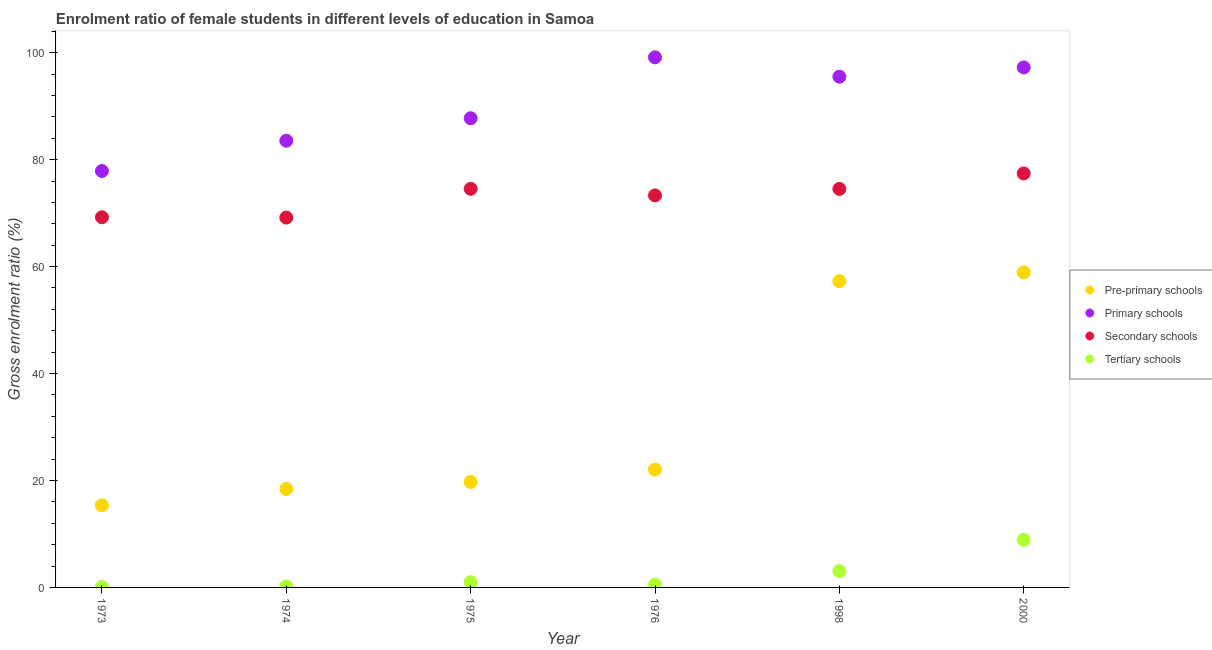How many different coloured dotlines are there?
Your response must be concise. 4. Is the number of dotlines equal to the number of legend labels?
Provide a succinct answer. Yes. What is the gross enrolment ratio(male) in primary schools in 1976?
Make the answer very short. 99.14. Across all years, what is the maximum gross enrolment ratio(male) in pre-primary schools?
Give a very brief answer. 58.91. Across all years, what is the minimum gross enrolment ratio(male) in pre-primary schools?
Ensure brevity in your answer.  15.36. In which year was the gross enrolment ratio(male) in primary schools maximum?
Make the answer very short. 1976. What is the total gross enrolment ratio(male) in pre-primary schools in the graph?
Your answer should be very brief. 191.72. What is the difference between the gross enrolment ratio(male) in secondary schools in 1975 and that in 1976?
Make the answer very short. 1.23. What is the difference between the gross enrolment ratio(male) in primary schools in 1976 and the gross enrolment ratio(male) in secondary schools in 1973?
Your answer should be very brief. 29.91. What is the average gross enrolment ratio(male) in tertiary schools per year?
Give a very brief answer. 2.29. In the year 2000, what is the difference between the gross enrolment ratio(male) in pre-primary schools and gross enrolment ratio(male) in tertiary schools?
Ensure brevity in your answer.  50. What is the ratio of the gross enrolment ratio(male) in tertiary schools in 1975 to that in 2000?
Your response must be concise. 0.11. Is the gross enrolment ratio(male) in pre-primary schools in 1975 less than that in 2000?
Keep it short and to the point. Yes. Is the difference between the gross enrolment ratio(male) in secondary schools in 1973 and 2000 greater than the difference between the gross enrolment ratio(male) in pre-primary schools in 1973 and 2000?
Offer a terse response. Yes. What is the difference between the highest and the second highest gross enrolment ratio(male) in pre-primary schools?
Give a very brief answer. 1.63. What is the difference between the highest and the lowest gross enrolment ratio(male) in pre-primary schools?
Provide a succinct answer. 43.55. Is the sum of the gross enrolment ratio(male) in tertiary schools in 1975 and 1976 greater than the maximum gross enrolment ratio(male) in secondary schools across all years?
Ensure brevity in your answer.  No. Is it the case that in every year, the sum of the gross enrolment ratio(male) in pre-primary schools and gross enrolment ratio(male) in tertiary schools is greater than the sum of gross enrolment ratio(male) in primary schools and gross enrolment ratio(male) in secondary schools?
Your answer should be compact. No. Is the gross enrolment ratio(male) in pre-primary schools strictly less than the gross enrolment ratio(male) in primary schools over the years?
Provide a short and direct response. Yes. How many years are there in the graph?
Ensure brevity in your answer.  6. Are the values on the major ticks of Y-axis written in scientific E-notation?
Give a very brief answer. No. Does the graph contain any zero values?
Offer a terse response. No. Does the graph contain grids?
Your answer should be compact. No. Where does the legend appear in the graph?
Provide a short and direct response. Center right. How are the legend labels stacked?
Keep it short and to the point. Vertical. What is the title of the graph?
Provide a succinct answer. Enrolment ratio of female students in different levels of education in Samoa. What is the label or title of the Y-axis?
Provide a succinct answer. Gross enrolment ratio (%). What is the Gross enrolment ratio (%) in Pre-primary schools in 1973?
Provide a short and direct response. 15.36. What is the Gross enrolment ratio (%) of Primary schools in 1973?
Your answer should be compact. 77.88. What is the Gross enrolment ratio (%) of Secondary schools in 1973?
Ensure brevity in your answer.  69.23. What is the Gross enrolment ratio (%) of Tertiary schools in 1973?
Provide a succinct answer. 0.09. What is the Gross enrolment ratio (%) of Pre-primary schools in 1974?
Make the answer very short. 18.42. What is the Gross enrolment ratio (%) of Primary schools in 1974?
Keep it short and to the point. 83.54. What is the Gross enrolment ratio (%) in Secondary schools in 1974?
Ensure brevity in your answer.  69.17. What is the Gross enrolment ratio (%) of Tertiary schools in 1974?
Ensure brevity in your answer.  0.18. What is the Gross enrolment ratio (%) of Pre-primary schools in 1975?
Give a very brief answer. 19.73. What is the Gross enrolment ratio (%) in Primary schools in 1975?
Provide a short and direct response. 87.74. What is the Gross enrolment ratio (%) in Secondary schools in 1975?
Your answer should be very brief. 74.55. What is the Gross enrolment ratio (%) of Tertiary schools in 1975?
Your response must be concise. 0.98. What is the Gross enrolment ratio (%) in Pre-primary schools in 1976?
Give a very brief answer. 22.04. What is the Gross enrolment ratio (%) in Primary schools in 1976?
Offer a terse response. 99.14. What is the Gross enrolment ratio (%) in Secondary schools in 1976?
Your response must be concise. 73.32. What is the Gross enrolment ratio (%) of Tertiary schools in 1976?
Provide a succinct answer. 0.54. What is the Gross enrolment ratio (%) of Pre-primary schools in 1998?
Ensure brevity in your answer.  57.27. What is the Gross enrolment ratio (%) of Primary schools in 1998?
Offer a very short reply. 95.51. What is the Gross enrolment ratio (%) in Secondary schools in 1998?
Ensure brevity in your answer.  74.53. What is the Gross enrolment ratio (%) in Tertiary schools in 1998?
Keep it short and to the point. 3.05. What is the Gross enrolment ratio (%) of Pre-primary schools in 2000?
Offer a very short reply. 58.91. What is the Gross enrolment ratio (%) of Primary schools in 2000?
Your answer should be compact. 97.25. What is the Gross enrolment ratio (%) of Secondary schools in 2000?
Provide a short and direct response. 77.42. What is the Gross enrolment ratio (%) of Tertiary schools in 2000?
Keep it short and to the point. 8.91. Across all years, what is the maximum Gross enrolment ratio (%) in Pre-primary schools?
Make the answer very short. 58.91. Across all years, what is the maximum Gross enrolment ratio (%) in Primary schools?
Offer a very short reply. 99.14. Across all years, what is the maximum Gross enrolment ratio (%) of Secondary schools?
Your answer should be compact. 77.42. Across all years, what is the maximum Gross enrolment ratio (%) in Tertiary schools?
Make the answer very short. 8.91. Across all years, what is the minimum Gross enrolment ratio (%) in Pre-primary schools?
Provide a succinct answer. 15.36. Across all years, what is the minimum Gross enrolment ratio (%) of Primary schools?
Provide a succinct answer. 77.88. Across all years, what is the minimum Gross enrolment ratio (%) of Secondary schools?
Your response must be concise. 69.17. Across all years, what is the minimum Gross enrolment ratio (%) in Tertiary schools?
Your answer should be compact. 0.09. What is the total Gross enrolment ratio (%) of Pre-primary schools in the graph?
Provide a short and direct response. 191.72. What is the total Gross enrolment ratio (%) in Primary schools in the graph?
Make the answer very short. 541.07. What is the total Gross enrolment ratio (%) in Secondary schools in the graph?
Offer a very short reply. 438.2. What is the total Gross enrolment ratio (%) in Tertiary schools in the graph?
Offer a terse response. 13.75. What is the difference between the Gross enrolment ratio (%) of Pre-primary schools in 1973 and that in 1974?
Ensure brevity in your answer.  -3.06. What is the difference between the Gross enrolment ratio (%) of Primary schools in 1973 and that in 1974?
Your response must be concise. -5.66. What is the difference between the Gross enrolment ratio (%) of Secondary schools in 1973 and that in 1974?
Provide a succinct answer. 0.06. What is the difference between the Gross enrolment ratio (%) of Tertiary schools in 1973 and that in 1974?
Give a very brief answer. -0.09. What is the difference between the Gross enrolment ratio (%) of Pre-primary schools in 1973 and that in 1975?
Provide a succinct answer. -4.38. What is the difference between the Gross enrolment ratio (%) of Primary schools in 1973 and that in 1975?
Offer a terse response. -9.86. What is the difference between the Gross enrolment ratio (%) in Secondary schools in 1973 and that in 1975?
Offer a terse response. -5.32. What is the difference between the Gross enrolment ratio (%) of Tertiary schools in 1973 and that in 1975?
Keep it short and to the point. -0.88. What is the difference between the Gross enrolment ratio (%) of Pre-primary schools in 1973 and that in 1976?
Your response must be concise. -6.68. What is the difference between the Gross enrolment ratio (%) in Primary schools in 1973 and that in 1976?
Offer a very short reply. -21.26. What is the difference between the Gross enrolment ratio (%) in Secondary schools in 1973 and that in 1976?
Keep it short and to the point. -4.09. What is the difference between the Gross enrolment ratio (%) in Tertiary schools in 1973 and that in 1976?
Offer a very short reply. -0.44. What is the difference between the Gross enrolment ratio (%) of Pre-primary schools in 1973 and that in 1998?
Keep it short and to the point. -41.92. What is the difference between the Gross enrolment ratio (%) in Primary schools in 1973 and that in 1998?
Provide a succinct answer. -17.63. What is the difference between the Gross enrolment ratio (%) in Secondary schools in 1973 and that in 1998?
Offer a very short reply. -5.3. What is the difference between the Gross enrolment ratio (%) in Tertiary schools in 1973 and that in 1998?
Keep it short and to the point. -2.96. What is the difference between the Gross enrolment ratio (%) of Pre-primary schools in 1973 and that in 2000?
Offer a terse response. -43.55. What is the difference between the Gross enrolment ratio (%) in Primary schools in 1973 and that in 2000?
Give a very brief answer. -19.37. What is the difference between the Gross enrolment ratio (%) in Secondary schools in 1973 and that in 2000?
Provide a succinct answer. -8.2. What is the difference between the Gross enrolment ratio (%) of Tertiary schools in 1973 and that in 2000?
Your answer should be very brief. -8.81. What is the difference between the Gross enrolment ratio (%) in Pre-primary schools in 1974 and that in 1975?
Ensure brevity in your answer.  -1.31. What is the difference between the Gross enrolment ratio (%) of Primary schools in 1974 and that in 1975?
Your answer should be very brief. -4.21. What is the difference between the Gross enrolment ratio (%) in Secondary schools in 1974 and that in 1975?
Give a very brief answer. -5.38. What is the difference between the Gross enrolment ratio (%) of Tertiary schools in 1974 and that in 1975?
Provide a succinct answer. -0.8. What is the difference between the Gross enrolment ratio (%) in Pre-primary schools in 1974 and that in 1976?
Your response must be concise. -3.62. What is the difference between the Gross enrolment ratio (%) in Primary schools in 1974 and that in 1976?
Offer a terse response. -15.6. What is the difference between the Gross enrolment ratio (%) of Secondary schools in 1974 and that in 1976?
Provide a short and direct response. -4.15. What is the difference between the Gross enrolment ratio (%) in Tertiary schools in 1974 and that in 1976?
Give a very brief answer. -0.36. What is the difference between the Gross enrolment ratio (%) of Pre-primary schools in 1974 and that in 1998?
Offer a very short reply. -38.85. What is the difference between the Gross enrolment ratio (%) in Primary schools in 1974 and that in 1998?
Provide a succinct answer. -11.97. What is the difference between the Gross enrolment ratio (%) in Secondary schools in 1974 and that in 1998?
Your response must be concise. -5.36. What is the difference between the Gross enrolment ratio (%) of Tertiary schools in 1974 and that in 1998?
Your response must be concise. -2.87. What is the difference between the Gross enrolment ratio (%) of Pre-primary schools in 1974 and that in 2000?
Your answer should be compact. -40.49. What is the difference between the Gross enrolment ratio (%) in Primary schools in 1974 and that in 2000?
Keep it short and to the point. -13.71. What is the difference between the Gross enrolment ratio (%) of Secondary schools in 1974 and that in 2000?
Give a very brief answer. -8.26. What is the difference between the Gross enrolment ratio (%) of Tertiary schools in 1974 and that in 2000?
Your response must be concise. -8.73. What is the difference between the Gross enrolment ratio (%) in Pre-primary schools in 1975 and that in 1976?
Your response must be concise. -2.31. What is the difference between the Gross enrolment ratio (%) of Primary schools in 1975 and that in 1976?
Ensure brevity in your answer.  -11.4. What is the difference between the Gross enrolment ratio (%) of Secondary schools in 1975 and that in 1976?
Offer a terse response. 1.23. What is the difference between the Gross enrolment ratio (%) of Tertiary schools in 1975 and that in 1976?
Give a very brief answer. 0.44. What is the difference between the Gross enrolment ratio (%) in Pre-primary schools in 1975 and that in 1998?
Ensure brevity in your answer.  -37.54. What is the difference between the Gross enrolment ratio (%) in Primary schools in 1975 and that in 1998?
Your answer should be compact. -7.77. What is the difference between the Gross enrolment ratio (%) in Secondary schools in 1975 and that in 1998?
Offer a very short reply. 0.02. What is the difference between the Gross enrolment ratio (%) of Tertiary schools in 1975 and that in 1998?
Provide a short and direct response. -2.08. What is the difference between the Gross enrolment ratio (%) in Pre-primary schools in 1975 and that in 2000?
Offer a very short reply. -39.18. What is the difference between the Gross enrolment ratio (%) in Primary schools in 1975 and that in 2000?
Give a very brief answer. -9.51. What is the difference between the Gross enrolment ratio (%) in Secondary schools in 1975 and that in 2000?
Give a very brief answer. -2.88. What is the difference between the Gross enrolment ratio (%) in Tertiary schools in 1975 and that in 2000?
Keep it short and to the point. -7.93. What is the difference between the Gross enrolment ratio (%) of Pre-primary schools in 1976 and that in 1998?
Keep it short and to the point. -35.23. What is the difference between the Gross enrolment ratio (%) in Primary schools in 1976 and that in 1998?
Provide a short and direct response. 3.63. What is the difference between the Gross enrolment ratio (%) in Secondary schools in 1976 and that in 1998?
Offer a terse response. -1.21. What is the difference between the Gross enrolment ratio (%) of Tertiary schools in 1976 and that in 1998?
Provide a succinct answer. -2.52. What is the difference between the Gross enrolment ratio (%) in Pre-primary schools in 1976 and that in 2000?
Ensure brevity in your answer.  -36.87. What is the difference between the Gross enrolment ratio (%) of Primary schools in 1976 and that in 2000?
Ensure brevity in your answer.  1.89. What is the difference between the Gross enrolment ratio (%) in Secondary schools in 1976 and that in 2000?
Offer a very short reply. -4.11. What is the difference between the Gross enrolment ratio (%) of Tertiary schools in 1976 and that in 2000?
Offer a very short reply. -8.37. What is the difference between the Gross enrolment ratio (%) in Pre-primary schools in 1998 and that in 2000?
Your response must be concise. -1.63. What is the difference between the Gross enrolment ratio (%) of Primary schools in 1998 and that in 2000?
Ensure brevity in your answer.  -1.74. What is the difference between the Gross enrolment ratio (%) of Secondary schools in 1998 and that in 2000?
Provide a short and direct response. -2.9. What is the difference between the Gross enrolment ratio (%) in Tertiary schools in 1998 and that in 2000?
Provide a succinct answer. -5.85. What is the difference between the Gross enrolment ratio (%) in Pre-primary schools in 1973 and the Gross enrolment ratio (%) in Primary schools in 1974?
Keep it short and to the point. -68.18. What is the difference between the Gross enrolment ratio (%) of Pre-primary schools in 1973 and the Gross enrolment ratio (%) of Secondary schools in 1974?
Provide a succinct answer. -53.81. What is the difference between the Gross enrolment ratio (%) in Pre-primary schools in 1973 and the Gross enrolment ratio (%) in Tertiary schools in 1974?
Your answer should be very brief. 15.17. What is the difference between the Gross enrolment ratio (%) of Primary schools in 1973 and the Gross enrolment ratio (%) of Secondary schools in 1974?
Give a very brief answer. 8.72. What is the difference between the Gross enrolment ratio (%) of Primary schools in 1973 and the Gross enrolment ratio (%) of Tertiary schools in 1974?
Your answer should be very brief. 77.7. What is the difference between the Gross enrolment ratio (%) of Secondary schools in 1973 and the Gross enrolment ratio (%) of Tertiary schools in 1974?
Your answer should be compact. 69.05. What is the difference between the Gross enrolment ratio (%) of Pre-primary schools in 1973 and the Gross enrolment ratio (%) of Primary schools in 1975?
Keep it short and to the point. -72.39. What is the difference between the Gross enrolment ratio (%) in Pre-primary schools in 1973 and the Gross enrolment ratio (%) in Secondary schools in 1975?
Your answer should be very brief. -59.19. What is the difference between the Gross enrolment ratio (%) of Pre-primary schools in 1973 and the Gross enrolment ratio (%) of Tertiary schools in 1975?
Keep it short and to the point. 14.38. What is the difference between the Gross enrolment ratio (%) of Primary schools in 1973 and the Gross enrolment ratio (%) of Secondary schools in 1975?
Your answer should be very brief. 3.34. What is the difference between the Gross enrolment ratio (%) in Primary schools in 1973 and the Gross enrolment ratio (%) in Tertiary schools in 1975?
Offer a very short reply. 76.9. What is the difference between the Gross enrolment ratio (%) in Secondary schools in 1973 and the Gross enrolment ratio (%) in Tertiary schools in 1975?
Your response must be concise. 68.25. What is the difference between the Gross enrolment ratio (%) in Pre-primary schools in 1973 and the Gross enrolment ratio (%) in Primary schools in 1976?
Make the answer very short. -83.79. What is the difference between the Gross enrolment ratio (%) of Pre-primary schools in 1973 and the Gross enrolment ratio (%) of Secondary schools in 1976?
Offer a very short reply. -57.96. What is the difference between the Gross enrolment ratio (%) in Pre-primary schools in 1973 and the Gross enrolment ratio (%) in Tertiary schools in 1976?
Your answer should be very brief. 14.82. What is the difference between the Gross enrolment ratio (%) of Primary schools in 1973 and the Gross enrolment ratio (%) of Secondary schools in 1976?
Offer a very short reply. 4.57. What is the difference between the Gross enrolment ratio (%) in Primary schools in 1973 and the Gross enrolment ratio (%) in Tertiary schools in 1976?
Offer a terse response. 77.35. What is the difference between the Gross enrolment ratio (%) in Secondary schools in 1973 and the Gross enrolment ratio (%) in Tertiary schools in 1976?
Your answer should be very brief. 68.69. What is the difference between the Gross enrolment ratio (%) of Pre-primary schools in 1973 and the Gross enrolment ratio (%) of Primary schools in 1998?
Offer a terse response. -80.16. What is the difference between the Gross enrolment ratio (%) of Pre-primary schools in 1973 and the Gross enrolment ratio (%) of Secondary schools in 1998?
Give a very brief answer. -59.17. What is the difference between the Gross enrolment ratio (%) of Pre-primary schools in 1973 and the Gross enrolment ratio (%) of Tertiary schools in 1998?
Offer a terse response. 12.3. What is the difference between the Gross enrolment ratio (%) of Primary schools in 1973 and the Gross enrolment ratio (%) of Secondary schools in 1998?
Offer a very short reply. 3.36. What is the difference between the Gross enrolment ratio (%) in Primary schools in 1973 and the Gross enrolment ratio (%) in Tertiary schools in 1998?
Make the answer very short. 74.83. What is the difference between the Gross enrolment ratio (%) of Secondary schools in 1973 and the Gross enrolment ratio (%) of Tertiary schools in 1998?
Offer a terse response. 66.17. What is the difference between the Gross enrolment ratio (%) in Pre-primary schools in 1973 and the Gross enrolment ratio (%) in Primary schools in 2000?
Your answer should be compact. -81.9. What is the difference between the Gross enrolment ratio (%) in Pre-primary schools in 1973 and the Gross enrolment ratio (%) in Secondary schools in 2000?
Offer a terse response. -62.07. What is the difference between the Gross enrolment ratio (%) in Pre-primary schools in 1973 and the Gross enrolment ratio (%) in Tertiary schools in 2000?
Offer a very short reply. 6.45. What is the difference between the Gross enrolment ratio (%) in Primary schools in 1973 and the Gross enrolment ratio (%) in Secondary schools in 2000?
Keep it short and to the point. 0.46. What is the difference between the Gross enrolment ratio (%) of Primary schools in 1973 and the Gross enrolment ratio (%) of Tertiary schools in 2000?
Provide a succinct answer. 68.97. What is the difference between the Gross enrolment ratio (%) in Secondary schools in 1973 and the Gross enrolment ratio (%) in Tertiary schools in 2000?
Ensure brevity in your answer.  60.32. What is the difference between the Gross enrolment ratio (%) in Pre-primary schools in 1974 and the Gross enrolment ratio (%) in Primary schools in 1975?
Your answer should be compact. -69.33. What is the difference between the Gross enrolment ratio (%) of Pre-primary schools in 1974 and the Gross enrolment ratio (%) of Secondary schools in 1975?
Offer a terse response. -56.13. What is the difference between the Gross enrolment ratio (%) of Pre-primary schools in 1974 and the Gross enrolment ratio (%) of Tertiary schools in 1975?
Your answer should be compact. 17.44. What is the difference between the Gross enrolment ratio (%) in Primary schools in 1974 and the Gross enrolment ratio (%) in Secondary schools in 1975?
Your response must be concise. 8.99. What is the difference between the Gross enrolment ratio (%) in Primary schools in 1974 and the Gross enrolment ratio (%) in Tertiary schools in 1975?
Ensure brevity in your answer.  82.56. What is the difference between the Gross enrolment ratio (%) of Secondary schools in 1974 and the Gross enrolment ratio (%) of Tertiary schools in 1975?
Provide a succinct answer. 68.19. What is the difference between the Gross enrolment ratio (%) in Pre-primary schools in 1974 and the Gross enrolment ratio (%) in Primary schools in 1976?
Give a very brief answer. -80.72. What is the difference between the Gross enrolment ratio (%) of Pre-primary schools in 1974 and the Gross enrolment ratio (%) of Secondary schools in 1976?
Provide a succinct answer. -54.9. What is the difference between the Gross enrolment ratio (%) of Pre-primary schools in 1974 and the Gross enrolment ratio (%) of Tertiary schools in 1976?
Your answer should be very brief. 17.88. What is the difference between the Gross enrolment ratio (%) in Primary schools in 1974 and the Gross enrolment ratio (%) in Secondary schools in 1976?
Make the answer very short. 10.22. What is the difference between the Gross enrolment ratio (%) of Primary schools in 1974 and the Gross enrolment ratio (%) of Tertiary schools in 1976?
Ensure brevity in your answer.  83. What is the difference between the Gross enrolment ratio (%) in Secondary schools in 1974 and the Gross enrolment ratio (%) in Tertiary schools in 1976?
Your answer should be compact. 68.63. What is the difference between the Gross enrolment ratio (%) in Pre-primary schools in 1974 and the Gross enrolment ratio (%) in Primary schools in 1998?
Make the answer very short. -77.09. What is the difference between the Gross enrolment ratio (%) of Pre-primary schools in 1974 and the Gross enrolment ratio (%) of Secondary schools in 1998?
Provide a succinct answer. -56.11. What is the difference between the Gross enrolment ratio (%) of Pre-primary schools in 1974 and the Gross enrolment ratio (%) of Tertiary schools in 1998?
Offer a terse response. 15.36. What is the difference between the Gross enrolment ratio (%) of Primary schools in 1974 and the Gross enrolment ratio (%) of Secondary schools in 1998?
Make the answer very short. 9.01. What is the difference between the Gross enrolment ratio (%) in Primary schools in 1974 and the Gross enrolment ratio (%) in Tertiary schools in 1998?
Ensure brevity in your answer.  80.49. What is the difference between the Gross enrolment ratio (%) in Secondary schools in 1974 and the Gross enrolment ratio (%) in Tertiary schools in 1998?
Your answer should be compact. 66.11. What is the difference between the Gross enrolment ratio (%) of Pre-primary schools in 1974 and the Gross enrolment ratio (%) of Primary schools in 2000?
Offer a terse response. -78.83. What is the difference between the Gross enrolment ratio (%) in Pre-primary schools in 1974 and the Gross enrolment ratio (%) in Secondary schools in 2000?
Offer a very short reply. -59. What is the difference between the Gross enrolment ratio (%) of Pre-primary schools in 1974 and the Gross enrolment ratio (%) of Tertiary schools in 2000?
Your answer should be very brief. 9.51. What is the difference between the Gross enrolment ratio (%) in Primary schools in 1974 and the Gross enrolment ratio (%) in Secondary schools in 2000?
Your response must be concise. 6.12. What is the difference between the Gross enrolment ratio (%) in Primary schools in 1974 and the Gross enrolment ratio (%) in Tertiary schools in 2000?
Provide a short and direct response. 74.63. What is the difference between the Gross enrolment ratio (%) of Secondary schools in 1974 and the Gross enrolment ratio (%) of Tertiary schools in 2000?
Your answer should be compact. 60.26. What is the difference between the Gross enrolment ratio (%) in Pre-primary schools in 1975 and the Gross enrolment ratio (%) in Primary schools in 1976?
Provide a short and direct response. -79.41. What is the difference between the Gross enrolment ratio (%) of Pre-primary schools in 1975 and the Gross enrolment ratio (%) of Secondary schools in 1976?
Your answer should be compact. -53.58. What is the difference between the Gross enrolment ratio (%) in Pre-primary schools in 1975 and the Gross enrolment ratio (%) in Tertiary schools in 1976?
Your response must be concise. 19.19. What is the difference between the Gross enrolment ratio (%) of Primary schools in 1975 and the Gross enrolment ratio (%) of Secondary schools in 1976?
Your response must be concise. 14.43. What is the difference between the Gross enrolment ratio (%) of Primary schools in 1975 and the Gross enrolment ratio (%) of Tertiary schools in 1976?
Offer a very short reply. 87.21. What is the difference between the Gross enrolment ratio (%) in Secondary schools in 1975 and the Gross enrolment ratio (%) in Tertiary schools in 1976?
Provide a short and direct response. 74.01. What is the difference between the Gross enrolment ratio (%) in Pre-primary schools in 1975 and the Gross enrolment ratio (%) in Primary schools in 1998?
Make the answer very short. -75.78. What is the difference between the Gross enrolment ratio (%) in Pre-primary schools in 1975 and the Gross enrolment ratio (%) in Secondary schools in 1998?
Your answer should be very brief. -54.8. What is the difference between the Gross enrolment ratio (%) in Pre-primary schools in 1975 and the Gross enrolment ratio (%) in Tertiary schools in 1998?
Your response must be concise. 16.68. What is the difference between the Gross enrolment ratio (%) of Primary schools in 1975 and the Gross enrolment ratio (%) of Secondary schools in 1998?
Provide a succinct answer. 13.22. What is the difference between the Gross enrolment ratio (%) of Primary schools in 1975 and the Gross enrolment ratio (%) of Tertiary schools in 1998?
Your response must be concise. 84.69. What is the difference between the Gross enrolment ratio (%) in Secondary schools in 1975 and the Gross enrolment ratio (%) in Tertiary schools in 1998?
Your answer should be compact. 71.49. What is the difference between the Gross enrolment ratio (%) in Pre-primary schools in 1975 and the Gross enrolment ratio (%) in Primary schools in 2000?
Ensure brevity in your answer.  -77.52. What is the difference between the Gross enrolment ratio (%) in Pre-primary schools in 1975 and the Gross enrolment ratio (%) in Secondary schools in 2000?
Offer a very short reply. -57.69. What is the difference between the Gross enrolment ratio (%) of Pre-primary schools in 1975 and the Gross enrolment ratio (%) of Tertiary schools in 2000?
Make the answer very short. 10.82. What is the difference between the Gross enrolment ratio (%) of Primary schools in 1975 and the Gross enrolment ratio (%) of Secondary schools in 2000?
Offer a very short reply. 10.32. What is the difference between the Gross enrolment ratio (%) of Primary schools in 1975 and the Gross enrolment ratio (%) of Tertiary schools in 2000?
Make the answer very short. 78.84. What is the difference between the Gross enrolment ratio (%) in Secondary schools in 1975 and the Gross enrolment ratio (%) in Tertiary schools in 2000?
Offer a terse response. 65.64. What is the difference between the Gross enrolment ratio (%) of Pre-primary schools in 1976 and the Gross enrolment ratio (%) of Primary schools in 1998?
Your answer should be compact. -73.47. What is the difference between the Gross enrolment ratio (%) in Pre-primary schools in 1976 and the Gross enrolment ratio (%) in Secondary schools in 1998?
Keep it short and to the point. -52.49. What is the difference between the Gross enrolment ratio (%) in Pre-primary schools in 1976 and the Gross enrolment ratio (%) in Tertiary schools in 1998?
Your response must be concise. 18.99. What is the difference between the Gross enrolment ratio (%) of Primary schools in 1976 and the Gross enrolment ratio (%) of Secondary schools in 1998?
Your response must be concise. 24.61. What is the difference between the Gross enrolment ratio (%) of Primary schools in 1976 and the Gross enrolment ratio (%) of Tertiary schools in 1998?
Keep it short and to the point. 96.09. What is the difference between the Gross enrolment ratio (%) of Secondary schools in 1976 and the Gross enrolment ratio (%) of Tertiary schools in 1998?
Offer a very short reply. 70.26. What is the difference between the Gross enrolment ratio (%) of Pre-primary schools in 1976 and the Gross enrolment ratio (%) of Primary schools in 2000?
Provide a short and direct response. -75.21. What is the difference between the Gross enrolment ratio (%) of Pre-primary schools in 1976 and the Gross enrolment ratio (%) of Secondary schools in 2000?
Provide a short and direct response. -55.38. What is the difference between the Gross enrolment ratio (%) in Pre-primary schools in 1976 and the Gross enrolment ratio (%) in Tertiary schools in 2000?
Give a very brief answer. 13.13. What is the difference between the Gross enrolment ratio (%) in Primary schools in 1976 and the Gross enrolment ratio (%) in Secondary schools in 2000?
Your response must be concise. 21.72. What is the difference between the Gross enrolment ratio (%) of Primary schools in 1976 and the Gross enrolment ratio (%) of Tertiary schools in 2000?
Ensure brevity in your answer.  90.23. What is the difference between the Gross enrolment ratio (%) in Secondary schools in 1976 and the Gross enrolment ratio (%) in Tertiary schools in 2000?
Your answer should be very brief. 64.41. What is the difference between the Gross enrolment ratio (%) in Pre-primary schools in 1998 and the Gross enrolment ratio (%) in Primary schools in 2000?
Keep it short and to the point. -39.98. What is the difference between the Gross enrolment ratio (%) in Pre-primary schools in 1998 and the Gross enrolment ratio (%) in Secondary schools in 2000?
Make the answer very short. -20.15. What is the difference between the Gross enrolment ratio (%) in Pre-primary schools in 1998 and the Gross enrolment ratio (%) in Tertiary schools in 2000?
Give a very brief answer. 48.36. What is the difference between the Gross enrolment ratio (%) of Primary schools in 1998 and the Gross enrolment ratio (%) of Secondary schools in 2000?
Keep it short and to the point. 18.09. What is the difference between the Gross enrolment ratio (%) in Primary schools in 1998 and the Gross enrolment ratio (%) in Tertiary schools in 2000?
Your response must be concise. 86.6. What is the difference between the Gross enrolment ratio (%) in Secondary schools in 1998 and the Gross enrolment ratio (%) in Tertiary schools in 2000?
Your answer should be very brief. 65.62. What is the average Gross enrolment ratio (%) of Pre-primary schools per year?
Your answer should be very brief. 31.95. What is the average Gross enrolment ratio (%) of Primary schools per year?
Your response must be concise. 90.18. What is the average Gross enrolment ratio (%) in Secondary schools per year?
Provide a succinct answer. 73.03. What is the average Gross enrolment ratio (%) in Tertiary schools per year?
Your answer should be compact. 2.29. In the year 1973, what is the difference between the Gross enrolment ratio (%) of Pre-primary schools and Gross enrolment ratio (%) of Primary schools?
Your answer should be very brief. -62.53. In the year 1973, what is the difference between the Gross enrolment ratio (%) of Pre-primary schools and Gross enrolment ratio (%) of Secondary schools?
Provide a succinct answer. -53.87. In the year 1973, what is the difference between the Gross enrolment ratio (%) in Pre-primary schools and Gross enrolment ratio (%) in Tertiary schools?
Offer a very short reply. 15.26. In the year 1973, what is the difference between the Gross enrolment ratio (%) of Primary schools and Gross enrolment ratio (%) of Secondary schools?
Make the answer very short. 8.65. In the year 1973, what is the difference between the Gross enrolment ratio (%) of Primary schools and Gross enrolment ratio (%) of Tertiary schools?
Your response must be concise. 77.79. In the year 1973, what is the difference between the Gross enrolment ratio (%) in Secondary schools and Gross enrolment ratio (%) in Tertiary schools?
Give a very brief answer. 69.13. In the year 1974, what is the difference between the Gross enrolment ratio (%) of Pre-primary schools and Gross enrolment ratio (%) of Primary schools?
Keep it short and to the point. -65.12. In the year 1974, what is the difference between the Gross enrolment ratio (%) in Pre-primary schools and Gross enrolment ratio (%) in Secondary schools?
Keep it short and to the point. -50.75. In the year 1974, what is the difference between the Gross enrolment ratio (%) of Pre-primary schools and Gross enrolment ratio (%) of Tertiary schools?
Your response must be concise. 18.24. In the year 1974, what is the difference between the Gross enrolment ratio (%) in Primary schools and Gross enrolment ratio (%) in Secondary schools?
Provide a succinct answer. 14.37. In the year 1974, what is the difference between the Gross enrolment ratio (%) of Primary schools and Gross enrolment ratio (%) of Tertiary schools?
Give a very brief answer. 83.36. In the year 1974, what is the difference between the Gross enrolment ratio (%) in Secondary schools and Gross enrolment ratio (%) in Tertiary schools?
Ensure brevity in your answer.  68.99. In the year 1975, what is the difference between the Gross enrolment ratio (%) in Pre-primary schools and Gross enrolment ratio (%) in Primary schools?
Offer a terse response. -68.01. In the year 1975, what is the difference between the Gross enrolment ratio (%) in Pre-primary schools and Gross enrolment ratio (%) in Secondary schools?
Make the answer very short. -54.81. In the year 1975, what is the difference between the Gross enrolment ratio (%) of Pre-primary schools and Gross enrolment ratio (%) of Tertiary schools?
Ensure brevity in your answer.  18.75. In the year 1975, what is the difference between the Gross enrolment ratio (%) of Primary schools and Gross enrolment ratio (%) of Secondary schools?
Give a very brief answer. 13.2. In the year 1975, what is the difference between the Gross enrolment ratio (%) of Primary schools and Gross enrolment ratio (%) of Tertiary schools?
Offer a very short reply. 86.77. In the year 1975, what is the difference between the Gross enrolment ratio (%) in Secondary schools and Gross enrolment ratio (%) in Tertiary schools?
Make the answer very short. 73.57. In the year 1976, what is the difference between the Gross enrolment ratio (%) in Pre-primary schools and Gross enrolment ratio (%) in Primary schools?
Provide a short and direct response. -77.1. In the year 1976, what is the difference between the Gross enrolment ratio (%) in Pre-primary schools and Gross enrolment ratio (%) in Secondary schools?
Make the answer very short. -51.28. In the year 1976, what is the difference between the Gross enrolment ratio (%) of Pre-primary schools and Gross enrolment ratio (%) of Tertiary schools?
Ensure brevity in your answer.  21.5. In the year 1976, what is the difference between the Gross enrolment ratio (%) in Primary schools and Gross enrolment ratio (%) in Secondary schools?
Make the answer very short. 25.83. In the year 1976, what is the difference between the Gross enrolment ratio (%) in Primary schools and Gross enrolment ratio (%) in Tertiary schools?
Provide a short and direct response. 98.6. In the year 1976, what is the difference between the Gross enrolment ratio (%) in Secondary schools and Gross enrolment ratio (%) in Tertiary schools?
Provide a short and direct response. 72.78. In the year 1998, what is the difference between the Gross enrolment ratio (%) of Pre-primary schools and Gross enrolment ratio (%) of Primary schools?
Ensure brevity in your answer.  -38.24. In the year 1998, what is the difference between the Gross enrolment ratio (%) in Pre-primary schools and Gross enrolment ratio (%) in Secondary schools?
Your answer should be compact. -17.25. In the year 1998, what is the difference between the Gross enrolment ratio (%) in Pre-primary schools and Gross enrolment ratio (%) in Tertiary schools?
Give a very brief answer. 54.22. In the year 1998, what is the difference between the Gross enrolment ratio (%) in Primary schools and Gross enrolment ratio (%) in Secondary schools?
Your answer should be very brief. 20.99. In the year 1998, what is the difference between the Gross enrolment ratio (%) in Primary schools and Gross enrolment ratio (%) in Tertiary schools?
Provide a succinct answer. 92.46. In the year 1998, what is the difference between the Gross enrolment ratio (%) of Secondary schools and Gross enrolment ratio (%) of Tertiary schools?
Keep it short and to the point. 71.47. In the year 2000, what is the difference between the Gross enrolment ratio (%) of Pre-primary schools and Gross enrolment ratio (%) of Primary schools?
Make the answer very short. -38.35. In the year 2000, what is the difference between the Gross enrolment ratio (%) of Pre-primary schools and Gross enrolment ratio (%) of Secondary schools?
Your answer should be compact. -18.52. In the year 2000, what is the difference between the Gross enrolment ratio (%) in Pre-primary schools and Gross enrolment ratio (%) in Tertiary schools?
Your response must be concise. 50. In the year 2000, what is the difference between the Gross enrolment ratio (%) in Primary schools and Gross enrolment ratio (%) in Secondary schools?
Provide a short and direct response. 19.83. In the year 2000, what is the difference between the Gross enrolment ratio (%) in Primary schools and Gross enrolment ratio (%) in Tertiary schools?
Your response must be concise. 88.34. In the year 2000, what is the difference between the Gross enrolment ratio (%) of Secondary schools and Gross enrolment ratio (%) of Tertiary schools?
Give a very brief answer. 68.51. What is the ratio of the Gross enrolment ratio (%) of Pre-primary schools in 1973 to that in 1974?
Give a very brief answer. 0.83. What is the ratio of the Gross enrolment ratio (%) in Primary schools in 1973 to that in 1974?
Ensure brevity in your answer.  0.93. What is the ratio of the Gross enrolment ratio (%) of Secondary schools in 1973 to that in 1974?
Offer a very short reply. 1. What is the ratio of the Gross enrolment ratio (%) in Tertiary schools in 1973 to that in 1974?
Ensure brevity in your answer.  0.52. What is the ratio of the Gross enrolment ratio (%) of Pre-primary schools in 1973 to that in 1975?
Offer a terse response. 0.78. What is the ratio of the Gross enrolment ratio (%) of Primary schools in 1973 to that in 1975?
Your answer should be very brief. 0.89. What is the ratio of the Gross enrolment ratio (%) in Secondary schools in 1973 to that in 1975?
Make the answer very short. 0.93. What is the ratio of the Gross enrolment ratio (%) in Tertiary schools in 1973 to that in 1975?
Ensure brevity in your answer.  0.1. What is the ratio of the Gross enrolment ratio (%) of Pre-primary schools in 1973 to that in 1976?
Provide a succinct answer. 0.7. What is the ratio of the Gross enrolment ratio (%) in Primary schools in 1973 to that in 1976?
Provide a succinct answer. 0.79. What is the ratio of the Gross enrolment ratio (%) of Secondary schools in 1973 to that in 1976?
Make the answer very short. 0.94. What is the ratio of the Gross enrolment ratio (%) in Tertiary schools in 1973 to that in 1976?
Give a very brief answer. 0.18. What is the ratio of the Gross enrolment ratio (%) of Pre-primary schools in 1973 to that in 1998?
Ensure brevity in your answer.  0.27. What is the ratio of the Gross enrolment ratio (%) of Primary schools in 1973 to that in 1998?
Provide a succinct answer. 0.82. What is the ratio of the Gross enrolment ratio (%) of Secondary schools in 1973 to that in 1998?
Provide a succinct answer. 0.93. What is the ratio of the Gross enrolment ratio (%) in Tertiary schools in 1973 to that in 1998?
Offer a very short reply. 0.03. What is the ratio of the Gross enrolment ratio (%) in Pre-primary schools in 1973 to that in 2000?
Make the answer very short. 0.26. What is the ratio of the Gross enrolment ratio (%) in Primary schools in 1973 to that in 2000?
Keep it short and to the point. 0.8. What is the ratio of the Gross enrolment ratio (%) in Secondary schools in 1973 to that in 2000?
Give a very brief answer. 0.89. What is the ratio of the Gross enrolment ratio (%) of Tertiary schools in 1973 to that in 2000?
Give a very brief answer. 0.01. What is the ratio of the Gross enrolment ratio (%) of Pre-primary schools in 1974 to that in 1975?
Keep it short and to the point. 0.93. What is the ratio of the Gross enrolment ratio (%) in Primary schools in 1974 to that in 1975?
Ensure brevity in your answer.  0.95. What is the ratio of the Gross enrolment ratio (%) of Secondary schools in 1974 to that in 1975?
Your answer should be very brief. 0.93. What is the ratio of the Gross enrolment ratio (%) in Tertiary schools in 1974 to that in 1975?
Your answer should be very brief. 0.18. What is the ratio of the Gross enrolment ratio (%) in Pre-primary schools in 1974 to that in 1976?
Your answer should be compact. 0.84. What is the ratio of the Gross enrolment ratio (%) in Primary schools in 1974 to that in 1976?
Offer a terse response. 0.84. What is the ratio of the Gross enrolment ratio (%) in Secondary schools in 1974 to that in 1976?
Offer a terse response. 0.94. What is the ratio of the Gross enrolment ratio (%) of Tertiary schools in 1974 to that in 1976?
Your answer should be very brief. 0.34. What is the ratio of the Gross enrolment ratio (%) in Pre-primary schools in 1974 to that in 1998?
Provide a short and direct response. 0.32. What is the ratio of the Gross enrolment ratio (%) in Primary schools in 1974 to that in 1998?
Keep it short and to the point. 0.87. What is the ratio of the Gross enrolment ratio (%) in Secondary schools in 1974 to that in 1998?
Give a very brief answer. 0.93. What is the ratio of the Gross enrolment ratio (%) of Tertiary schools in 1974 to that in 1998?
Offer a terse response. 0.06. What is the ratio of the Gross enrolment ratio (%) in Pre-primary schools in 1974 to that in 2000?
Keep it short and to the point. 0.31. What is the ratio of the Gross enrolment ratio (%) of Primary schools in 1974 to that in 2000?
Provide a succinct answer. 0.86. What is the ratio of the Gross enrolment ratio (%) of Secondary schools in 1974 to that in 2000?
Offer a terse response. 0.89. What is the ratio of the Gross enrolment ratio (%) in Tertiary schools in 1974 to that in 2000?
Give a very brief answer. 0.02. What is the ratio of the Gross enrolment ratio (%) of Pre-primary schools in 1975 to that in 1976?
Provide a succinct answer. 0.9. What is the ratio of the Gross enrolment ratio (%) of Primary schools in 1975 to that in 1976?
Ensure brevity in your answer.  0.89. What is the ratio of the Gross enrolment ratio (%) in Secondary schools in 1975 to that in 1976?
Make the answer very short. 1.02. What is the ratio of the Gross enrolment ratio (%) in Tertiary schools in 1975 to that in 1976?
Offer a very short reply. 1.82. What is the ratio of the Gross enrolment ratio (%) in Pre-primary schools in 1975 to that in 1998?
Give a very brief answer. 0.34. What is the ratio of the Gross enrolment ratio (%) in Primary schools in 1975 to that in 1998?
Make the answer very short. 0.92. What is the ratio of the Gross enrolment ratio (%) of Secondary schools in 1975 to that in 1998?
Keep it short and to the point. 1. What is the ratio of the Gross enrolment ratio (%) in Tertiary schools in 1975 to that in 1998?
Ensure brevity in your answer.  0.32. What is the ratio of the Gross enrolment ratio (%) of Pre-primary schools in 1975 to that in 2000?
Make the answer very short. 0.34. What is the ratio of the Gross enrolment ratio (%) in Primary schools in 1975 to that in 2000?
Provide a short and direct response. 0.9. What is the ratio of the Gross enrolment ratio (%) in Secondary schools in 1975 to that in 2000?
Your answer should be compact. 0.96. What is the ratio of the Gross enrolment ratio (%) in Tertiary schools in 1975 to that in 2000?
Keep it short and to the point. 0.11. What is the ratio of the Gross enrolment ratio (%) in Pre-primary schools in 1976 to that in 1998?
Provide a short and direct response. 0.38. What is the ratio of the Gross enrolment ratio (%) in Primary schools in 1976 to that in 1998?
Offer a terse response. 1.04. What is the ratio of the Gross enrolment ratio (%) of Secondary schools in 1976 to that in 1998?
Offer a terse response. 0.98. What is the ratio of the Gross enrolment ratio (%) of Tertiary schools in 1976 to that in 1998?
Offer a very short reply. 0.18. What is the ratio of the Gross enrolment ratio (%) in Pre-primary schools in 1976 to that in 2000?
Offer a terse response. 0.37. What is the ratio of the Gross enrolment ratio (%) in Primary schools in 1976 to that in 2000?
Give a very brief answer. 1.02. What is the ratio of the Gross enrolment ratio (%) in Secondary schools in 1976 to that in 2000?
Your response must be concise. 0.95. What is the ratio of the Gross enrolment ratio (%) in Tertiary schools in 1976 to that in 2000?
Give a very brief answer. 0.06. What is the ratio of the Gross enrolment ratio (%) in Pre-primary schools in 1998 to that in 2000?
Ensure brevity in your answer.  0.97. What is the ratio of the Gross enrolment ratio (%) of Primary schools in 1998 to that in 2000?
Provide a succinct answer. 0.98. What is the ratio of the Gross enrolment ratio (%) of Secondary schools in 1998 to that in 2000?
Offer a very short reply. 0.96. What is the ratio of the Gross enrolment ratio (%) in Tertiary schools in 1998 to that in 2000?
Make the answer very short. 0.34. What is the difference between the highest and the second highest Gross enrolment ratio (%) in Pre-primary schools?
Provide a succinct answer. 1.63. What is the difference between the highest and the second highest Gross enrolment ratio (%) of Primary schools?
Make the answer very short. 1.89. What is the difference between the highest and the second highest Gross enrolment ratio (%) of Secondary schools?
Give a very brief answer. 2.88. What is the difference between the highest and the second highest Gross enrolment ratio (%) in Tertiary schools?
Your answer should be compact. 5.85. What is the difference between the highest and the lowest Gross enrolment ratio (%) in Pre-primary schools?
Offer a very short reply. 43.55. What is the difference between the highest and the lowest Gross enrolment ratio (%) in Primary schools?
Ensure brevity in your answer.  21.26. What is the difference between the highest and the lowest Gross enrolment ratio (%) in Secondary schools?
Your answer should be compact. 8.26. What is the difference between the highest and the lowest Gross enrolment ratio (%) in Tertiary schools?
Your response must be concise. 8.81. 